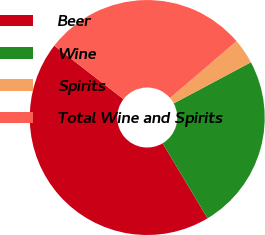<chart> <loc_0><loc_0><loc_500><loc_500><pie_chart><fcel>Beer<fcel>Wine<fcel>Spirits<fcel>Total Wine and Spirits<nl><fcel>44.06%<fcel>24.21%<fcel>3.47%<fcel>28.27%<nl></chart> 